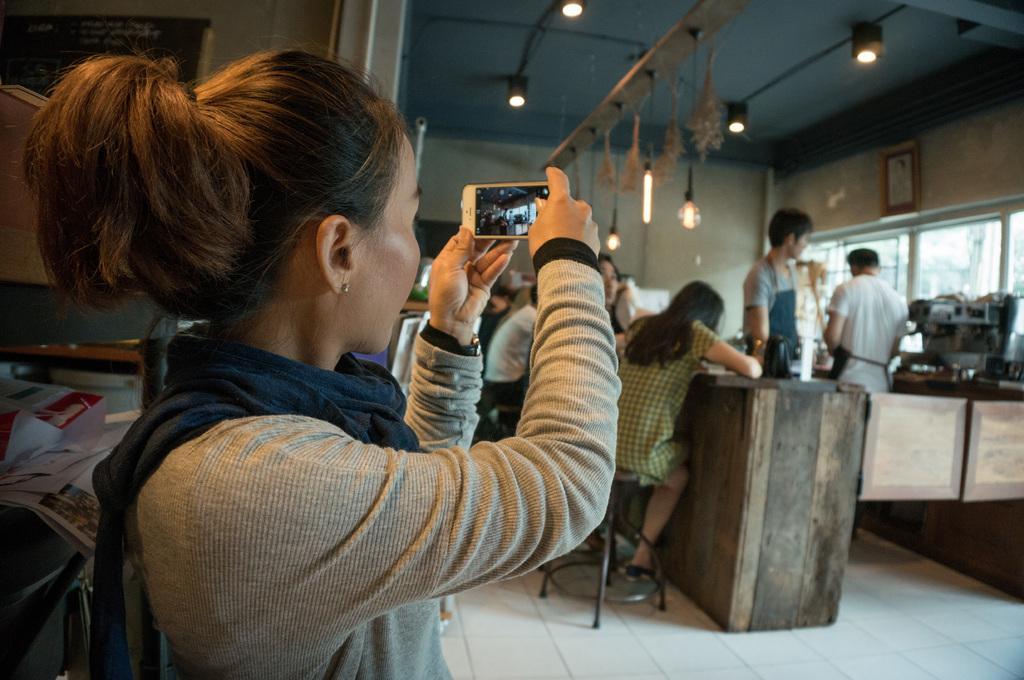Describe this image in one or two sentences. In this image I can see a woman holding a mobile in her hand. In the background I can see few persons standing, few persons sitting on chairs in front of the desk, the wall, the ceiling, few lights to the ceiling and the windows through which I can see few buildings and the sky. 